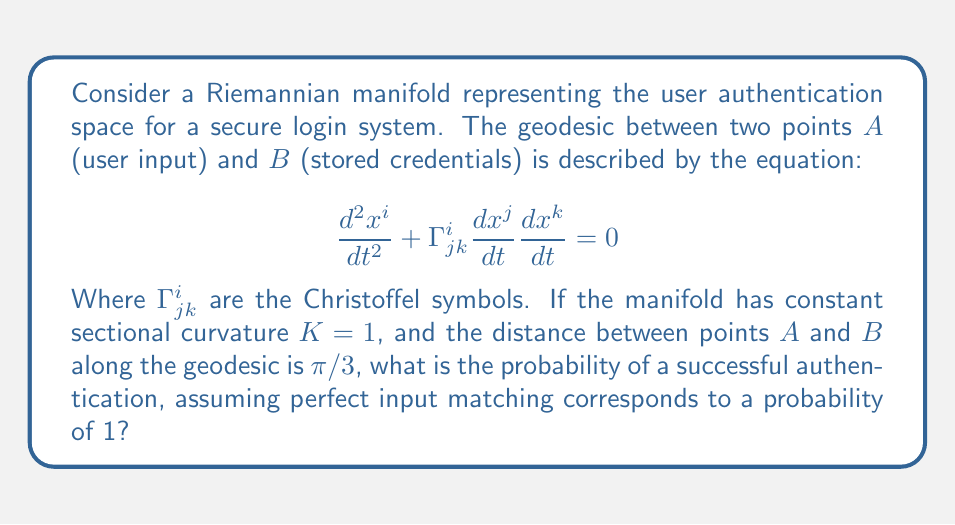Help me with this question. To solve this problem, we need to understand the relationship between geodesics on a Riemannian manifold and the authentication process:

1) In our model, the authentication process is represented by the geodesic path between user input (point $A$) and stored credentials (point $B$).

2) The manifold having constant sectional curvature $K = 1$ implies that it is a unit sphere in a higher-dimensional space.

3) On a unit sphere, the length of a geodesic is equal to the angle it subtends at the center (in radians).

4) We're given that the distance between $A$ and $B$ along the geodesic is $\pi/3$.

5) Perfect authentication (probability 1) would correspond to $A$ and $B$ being the same point, i.e., distance 0.

6) The worst case (probability 0) would be when $A$ and $B$ are antipodal points, with a distance of $\pi$.

7) We can model the probability as a linear function of the geodesic distance:

   $P = 1 - \frac{d}{\pi}$

   where $d$ is the geodesic distance and $\pi$ is the maximum possible distance.

8) Substituting our geodesic distance $d = \pi/3$:

   $P = 1 - \frac{\pi/3}{\pi} = 1 - \frac{1}{3} = \frac{2}{3}$

Therefore, the probability of successful authentication is $\frac{2}{3}$ or approximately 0.667.
Answer: $\frac{2}{3}$ 